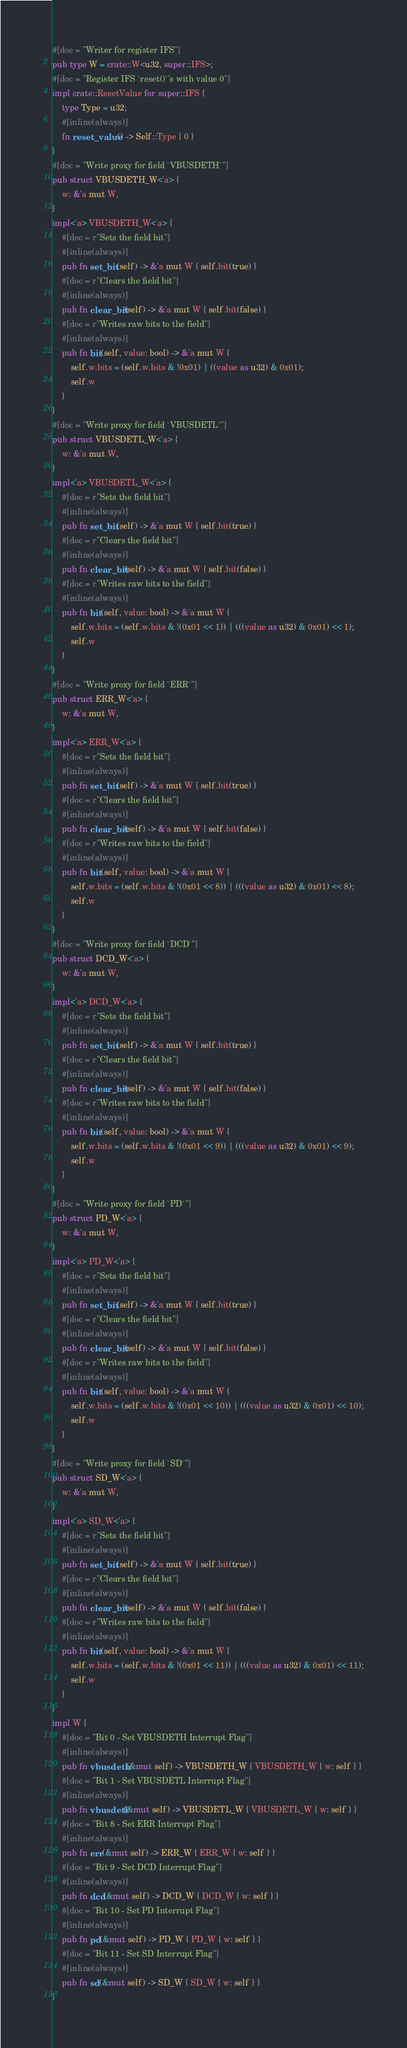<code> <loc_0><loc_0><loc_500><loc_500><_Rust_>#[doc = "Writer for register IFS"]
pub type W = crate::W<u32, super::IFS>;
#[doc = "Register IFS `reset()`'s with value 0"]
impl crate::ResetValue for super::IFS {
    type Type = u32;
    #[inline(always)]
    fn reset_value() -> Self::Type { 0 }
}
#[doc = "Write proxy for field `VBUSDETH`"]
pub struct VBUSDETH_W<'a> {
    w: &'a mut W,
}
impl<'a> VBUSDETH_W<'a> {
    #[doc = r"Sets the field bit"]
    #[inline(always)]
    pub fn set_bit(self) -> &'a mut W { self.bit(true) }
    #[doc = r"Clears the field bit"]
    #[inline(always)]
    pub fn clear_bit(self) -> &'a mut W { self.bit(false) }
    #[doc = r"Writes raw bits to the field"]
    #[inline(always)]
    pub fn bit(self, value: bool) -> &'a mut W {
        self.w.bits = (self.w.bits & !0x01) | ((value as u32) & 0x01);
        self.w
    }
}
#[doc = "Write proxy for field `VBUSDETL`"]
pub struct VBUSDETL_W<'a> {
    w: &'a mut W,
}
impl<'a> VBUSDETL_W<'a> {
    #[doc = r"Sets the field bit"]
    #[inline(always)]
    pub fn set_bit(self) -> &'a mut W { self.bit(true) }
    #[doc = r"Clears the field bit"]
    #[inline(always)]
    pub fn clear_bit(self) -> &'a mut W { self.bit(false) }
    #[doc = r"Writes raw bits to the field"]
    #[inline(always)]
    pub fn bit(self, value: bool) -> &'a mut W {
        self.w.bits = (self.w.bits & !(0x01 << 1)) | (((value as u32) & 0x01) << 1);
        self.w
    }
}
#[doc = "Write proxy for field `ERR`"]
pub struct ERR_W<'a> {
    w: &'a mut W,
}
impl<'a> ERR_W<'a> {
    #[doc = r"Sets the field bit"]
    #[inline(always)]
    pub fn set_bit(self) -> &'a mut W { self.bit(true) }
    #[doc = r"Clears the field bit"]
    #[inline(always)]
    pub fn clear_bit(self) -> &'a mut W { self.bit(false) }
    #[doc = r"Writes raw bits to the field"]
    #[inline(always)]
    pub fn bit(self, value: bool) -> &'a mut W {
        self.w.bits = (self.w.bits & !(0x01 << 8)) | (((value as u32) & 0x01) << 8);
        self.w
    }
}
#[doc = "Write proxy for field `DCD`"]
pub struct DCD_W<'a> {
    w: &'a mut W,
}
impl<'a> DCD_W<'a> {
    #[doc = r"Sets the field bit"]
    #[inline(always)]
    pub fn set_bit(self) -> &'a mut W { self.bit(true) }
    #[doc = r"Clears the field bit"]
    #[inline(always)]
    pub fn clear_bit(self) -> &'a mut W { self.bit(false) }
    #[doc = r"Writes raw bits to the field"]
    #[inline(always)]
    pub fn bit(self, value: bool) -> &'a mut W {
        self.w.bits = (self.w.bits & !(0x01 << 9)) | (((value as u32) & 0x01) << 9);
        self.w
    }
}
#[doc = "Write proxy for field `PD`"]
pub struct PD_W<'a> {
    w: &'a mut W,
}
impl<'a> PD_W<'a> {
    #[doc = r"Sets the field bit"]
    #[inline(always)]
    pub fn set_bit(self) -> &'a mut W { self.bit(true) }
    #[doc = r"Clears the field bit"]
    #[inline(always)]
    pub fn clear_bit(self) -> &'a mut W { self.bit(false) }
    #[doc = r"Writes raw bits to the field"]
    #[inline(always)]
    pub fn bit(self, value: bool) -> &'a mut W {
        self.w.bits = (self.w.bits & !(0x01 << 10)) | (((value as u32) & 0x01) << 10);
        self.w
    }
}
#[doc = "Write proxy for field `SD`"]
pub struct SD_W<'a> {
    w: &'a mut W,
}
impl<'a> SD_W<'a> {
    #[doc = r"Sets the field bit"]
    #[inline(always)]
    pub fn set_bit(self) -> &'a mut W { self.bit(true) }
    #[doc = r"Clears the field bit"]
    #[inline(always)]
    pub fn clear_bit(self) -> &'a mut W { self.bit(false) }
    #[doc = r"Writes raw bits to the field"]
    #[inline(always)]
    pub fn bit(self, value: bool) -> &'a mut W {
        self.w.bits = (self.w.bits & !(0x01 << 11)) | (((value as u32) & 0x01) << 11);
        self.w
    }
}
impl W {
    #[doc = "Bit 0 - Set VBUSDETH Interrupt Flag"]
    #[inline(always)]
    pub fn vbusdeth(&mut self) -> VBUSDETH_W { VBUSDETH_W { w: self } }
    #[doc = "Bit 1 - Set VBUSDETL Interrupt Flag"]
    #[inline(always)]
    pub fn vbusdetl(&mut self) -> VBUSDETL_W { VBUSDETL_W { w: self } }
    #[doc = "Bit 8 - Set ERR Interrupt Flag"]
    #[inline(always)]
    pub fn err(&mut self) -> ERR_W { ERR_W { w: self } }
    #[doc = "Bit 9 - Set DCD Interrupt Flag"]
    #[inline(always)]
    pub fn dcd(&mut self) -> DCD_W { DCD_W { w: self } }
    #[doc = "Bit 10 - Set PD Interrupt Flag"]
    #[inline(always)]
    pub fn pd(&mut self) -> PD_W { PD_W { w: self } }
    #[doc = "Bit 11 - Set SD Interrupt Flag"]
    #[inline(always)]
    pub fn sd(&mut self) -> SD_W { SD_W { w: self } }
}
</code> 